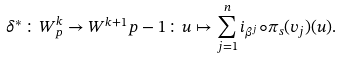<formula> <loc_0><loc_0><loc_500><loc_500>\delta ^ { * } \colon W ^ { k } _ { p } \rightarrow W ^ { k + 1 } { p - 1 } \colon u \mapsto \sum _ { j = 1 } ^ { n } i _ { \beta ^ { j } } \circ \pi _ { s } ( v _ { j } ) ( u ) .</formula> 